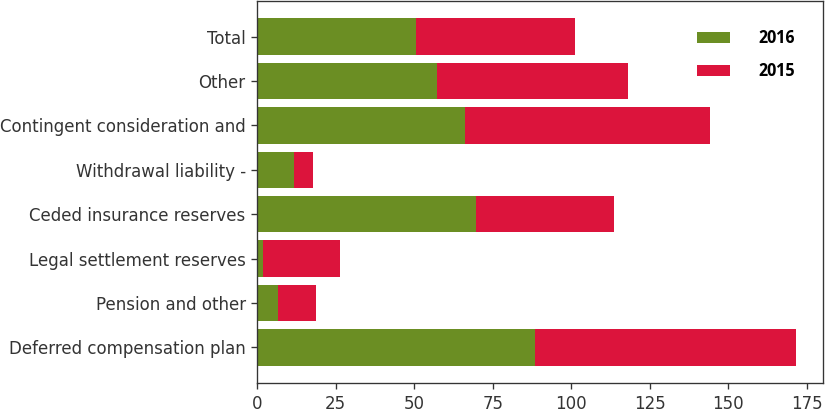Convert chart. <chart><loc_0><loc_0><loc_500><loc_500><stacked_bar_chart><ecel><fcel>Deferred compensation plan<fcel>Pension and other<fcel>Legal settlement reserves<fcel>Ceded insurance reserves<fcel>Withdrawal liability -<fcel>Contingent consideration and<fcel>Other<fcel>Total<nl><fcel>2016<fcel>88.3<fcel>6.7<fcel>1.7<fcel>69.7<fcel>11.7<fcel>66<fcel>57.1<fcel>50.55<nl><fcel>2015<fcel>83.3<fcel>12.1<fcel>24.7<fcel>44<fcel>6.1<fcel>78<fcel>61.1<fcel>50.55<nl></chart> 